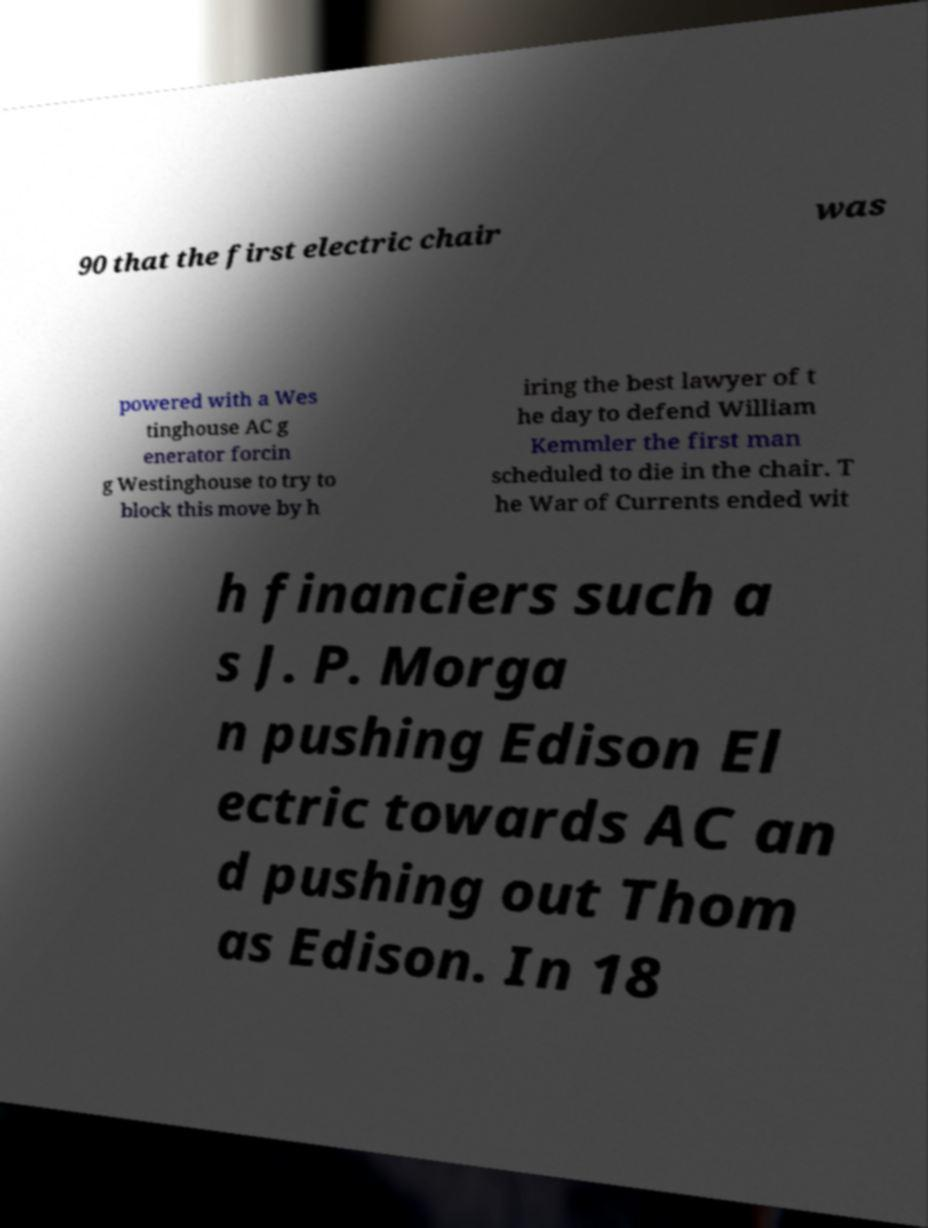There's text embedded in this image that I need extracted. Can you transcribe it verbatim? 90 that the first electric chair was powered with a Wes tinghouse AC g enerator forcin g Westinghouse to try to block this move by h iring the best lawyer of t he day to defend William Kemmler the first man scheduled to die in the chair. T he War of Currents ended wit h financiers such a s J. P. Morga n pushing Edison El ectric towards AC an d pushing out Thom as Edison. In 18 